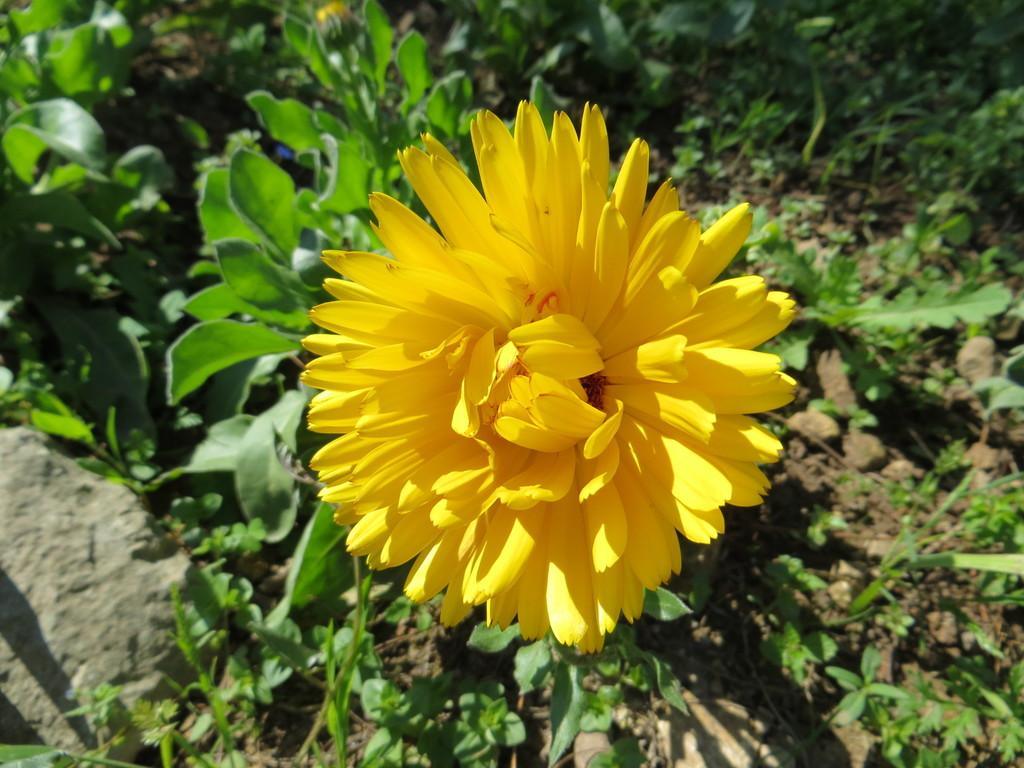What type of flower can be seen in the image? There is a yellow flower in the image. How many plants are visible in the image? There are multiple plants in the image. What is the texture of the ground in the image? There is mud visible in the image. What type of object can be seen in the image? There is a stone in the image. What type of sound does the salt make when it is sprinkled in the image? There is no salt present in the image, so it is not possible to determine the sound it would make if sprinkled. 